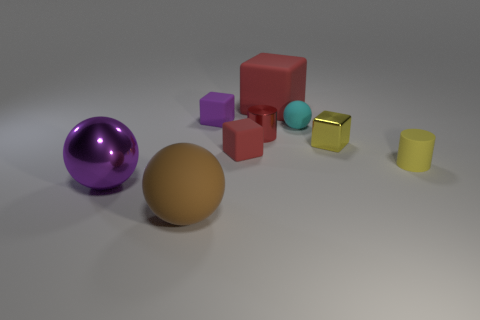Add 1 large shiny spheres. How many objects exist? 10 Subtract all matte blocks. How many blocks are left? 1 Subtract 1 spheres. How many spheres are left? 2 Subtract all red cylinders. How many cylinders are left? 1 Subtract all red cylinders. How many blue blocks are left? 0 Subtract all blue things. Subtract all tiny red shiny objects. How many objects are left? 8 Add 1 small yellow blocks. How many small yellow blocks are left? 2 Add 4 cubes. How many cubes exist? 8 Subtract 1 red cubes. How many objects are left? 8 Subtract all cubes. How many objects are left? 5 